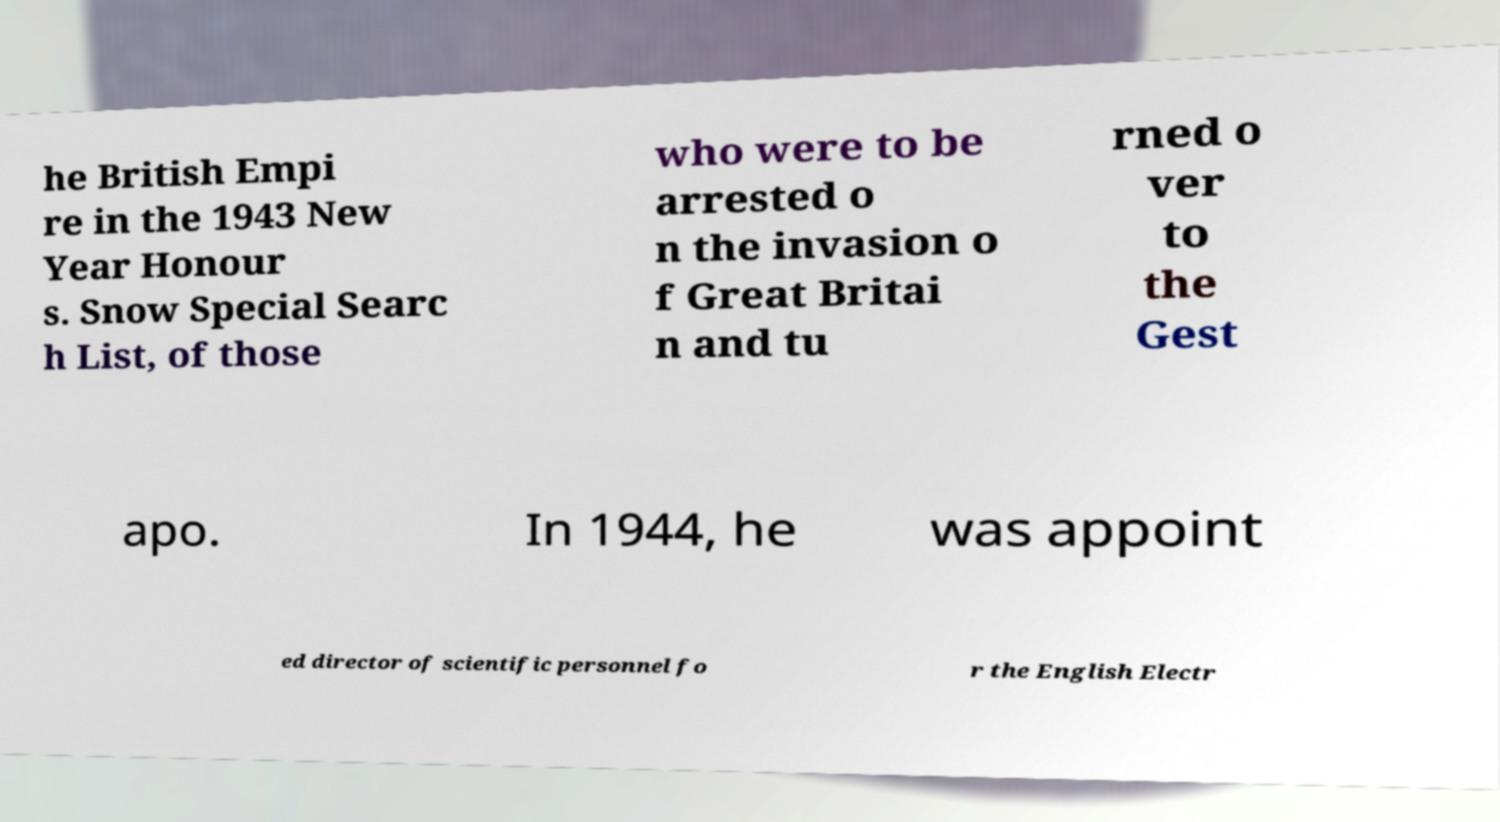Please identify and transcribe the text found in this image. he British Empi re in the 1943 New Year Honour s. Snow Special Searc h List, of those who were to be arrested o n the invasion o f Great Britai n and tu rned o ver to the Gest apo. In 1944, he was appoint ed director of scientific personnel fo r the English Electr 